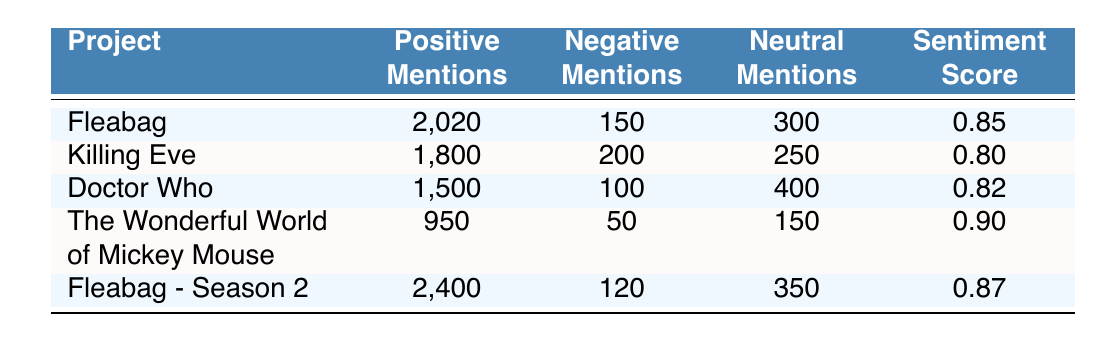What project had the highest positive mentions? Looking through the table, Fleabag - Season 2 has the highest count of positive mentions at 2,400.
Answer: Fleabag - Season 2 What is the overall sentiment score of Doctor Who? The table shows that the overall sentiment score of Doctor Who is 0.82.
Answer: 0.82 How many total mentions (positive + negative + neutral) does Fleabag have? To find the total mentions for Fleabag, we add positive mentions (2,020), negative mentions (150), and neutral mentions (300). This sums up to 2,020 + 150 + 300 = 2,470.
Answer: 2,470 Is the sentiment score for The Wonderful World of Mickey Mouse higher than that of Killing Eve? The sentiment score for The Wonderful World of Mickey Mouse is 0.90, which is indeed higher than Killing Eve's score of 0.80.
Answer: Yes What is the difference in the number of negative mentions between Fleabag and Fleabag - Season 2? We find the negative mentions for Fleabag (150) and Fleabag - Season 2 (120). The difference is 150 - 120 = 30.
Answer: 30 Which project has the lowest positive mentions among the listed projects? Evaluating the positive mentions, The Wonderful World of Mickey Mouse has the lowest at 950.
Answer: The Wonderful World of Mickey Mouse What is the average overall sentiment score for Fleabag and Fleabag - Season 2? The overall sentiment scores for Fleabag (0.85) and Fleabag - Season 2 (0.87) are summed: 0.85 + 0.87 = 1.72. To find the average, we divide by 2, giving us 1.72 / 2 = 0.86.
Answer: 0.86 Does Doctor Who have more total mentions than The Wonderful World of Mickey Mouse? The total mentions for Doctor Who are calculated as 1,500 + 100 + 400 = 2,000, while The Wonderful World of Mickey Mouse totals 950 + 50 + 150 = 1,150. Since 2,000 is greater than 1,150, the statement is true.
Answer: Yes How many projects listed have an overall sentiment score of 0.85 or higher? By reviewing the table, Fleabag (0.85), The Wonderful World of Mickey Mouse (0.90), Fleabag - Season 2 (0.87) all have scores of 0.85 or higher. This results in a count of 3 projects.
Answer: 3 